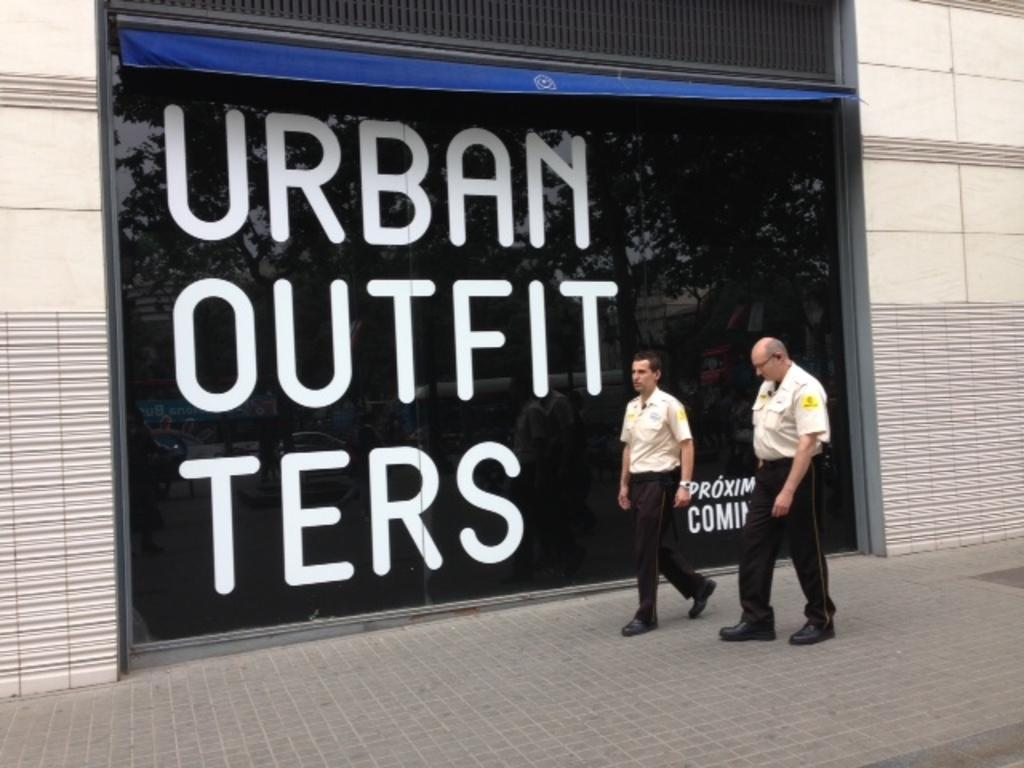What type of building is visible in the image? There is a building in the image, but the specific type cannot be determined from the provided facts. What is located near the building in the image? There is a fence in the image. What are the two persons in the image doing? Two persons are walking in the image. What can be seen written in the image? There is something written in the image, but the content cannot be determined from the provided facts. What is reflected in the image? There is a reflection of trees in the image. What type of pot is being used by the persons walking in the image? There is no pot present in the image; the two persons are walking. How many eggs are visible in the image? There are no eggs present in the image. 